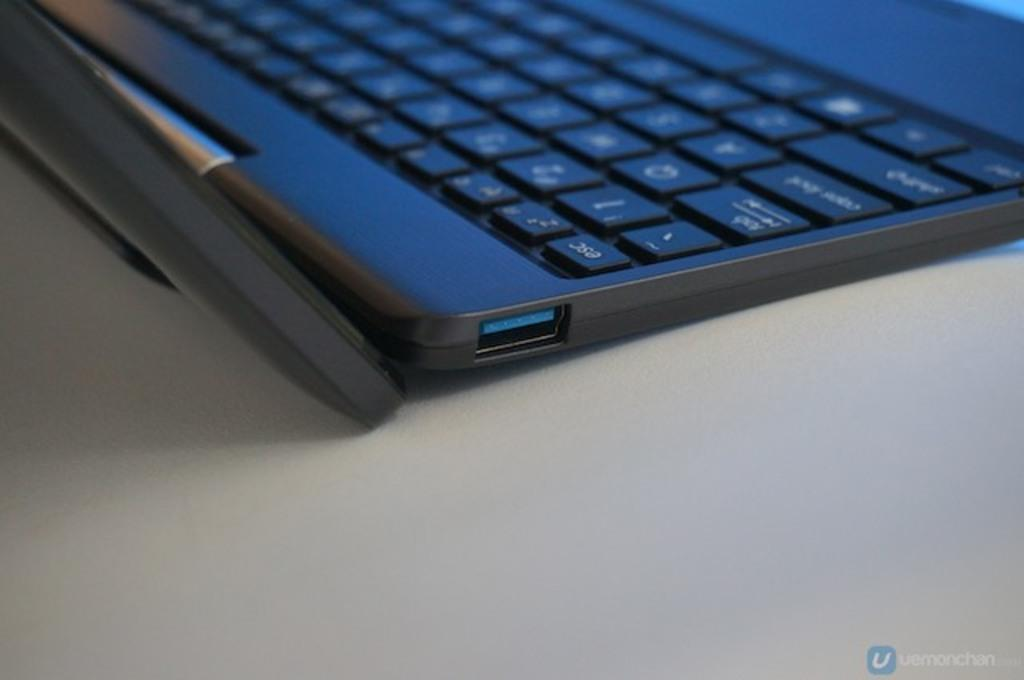Provide a one-sentence caption for the provided image. A close-up of a portion of a laptop with the ESC key visible. 